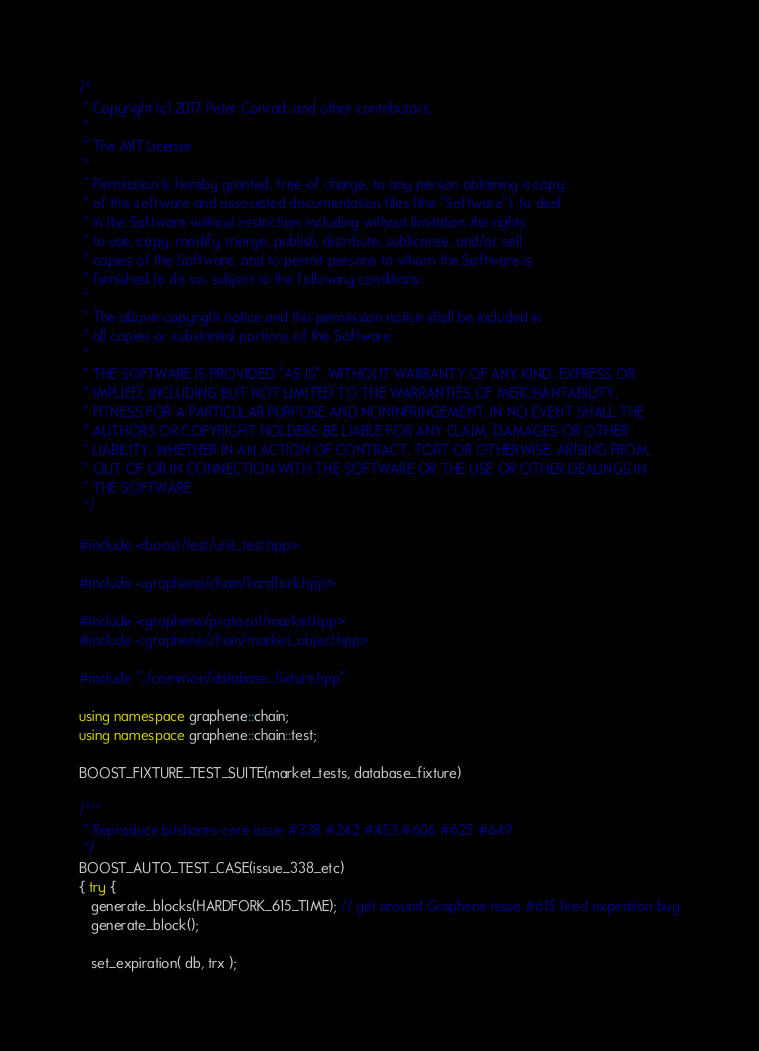Convert code to text. <code><loc_0><loc_0><loc_500><loc_500><_C++_>/*
 * Copyright (c) 2017 Peter Conrad, and other contributors.
 *
 * The MIT License
 *
 * Permission is hereby granted, free of charge, to any person obtaining a copy
 * of this software and associated documentation files (the "Software"), to deal
 * in the Software without restriction, including without limitation the rights
 * to use, copy, modify, merge, publish, distribute, sublicense, and/or sell
 * copies of the Software, and to permit persons to whom the Software is
 * furnished to do so, subject to the following conditions:
 *
 * The above copyright notice and this permission notice shall be included in
 * all copies or substantial portions of the Software.
 *
 * THE SOFTWARE IS PROVIDED "AS IS", WITHOUT WARRANTY OF ANY KIND, EXPRESS OR
 * IMPLIED, INCLUDING BUT NOT LIMITED TO THE WARRANTIES OF MERCHANTABILITY,
 * FITNESS FOR A PARTICULAR PURPOSE AND NONINFRINGEMENT. IN NO EVENT SHALL THE
 * AUTHORS OR COPYRIGHT HOLDERS BE LIABLE FOR ANY CLAIM, DAMAGES OR OTHER
 * LIABILITY, WHETHER IN AN ACTION OF CONTRACT, TORT OR OTHERWISE, ARISING FROM,
 * OUT OF OR IN CONNECTION WITH THE SOFTWARE OR THE USE OR OTHER DEALINGS IN
 * THE SOFTWARE.
 */

#include <boost/test/unit_test.hpp>

#include <graphene/chain/hardfork.hpp>

#include <graphene/protocol/market.hpp>
#include <graphene/chain/market_object.hpp>

#include "../common/database_fixture.hpp"

using namespace graphene::chain;
using namespace graphene::chain::test;

BOOST_FIXTURE_TEST_SUITE(market_tests, database_fixture)

/***
 * Reproduce bitshares-core issue #338 #343 #453 #606 #625 #649
 */
BOOST_AUTO_TEST_CASE(issue_338_etc)
{ try {
   generate_blocks(HARDFORK_615_TIME); // get around Graphene issue #615 feed expiration bug
   generate_block();

   set_expiration( db, trx );
</code> 